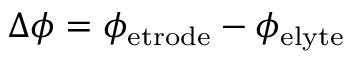<formula> <loc_0><loc_0><loc_500><loc_500>\Delta \phi = \phi _ { e t r o d e } - \phi _ { e l y t e }</formula> 